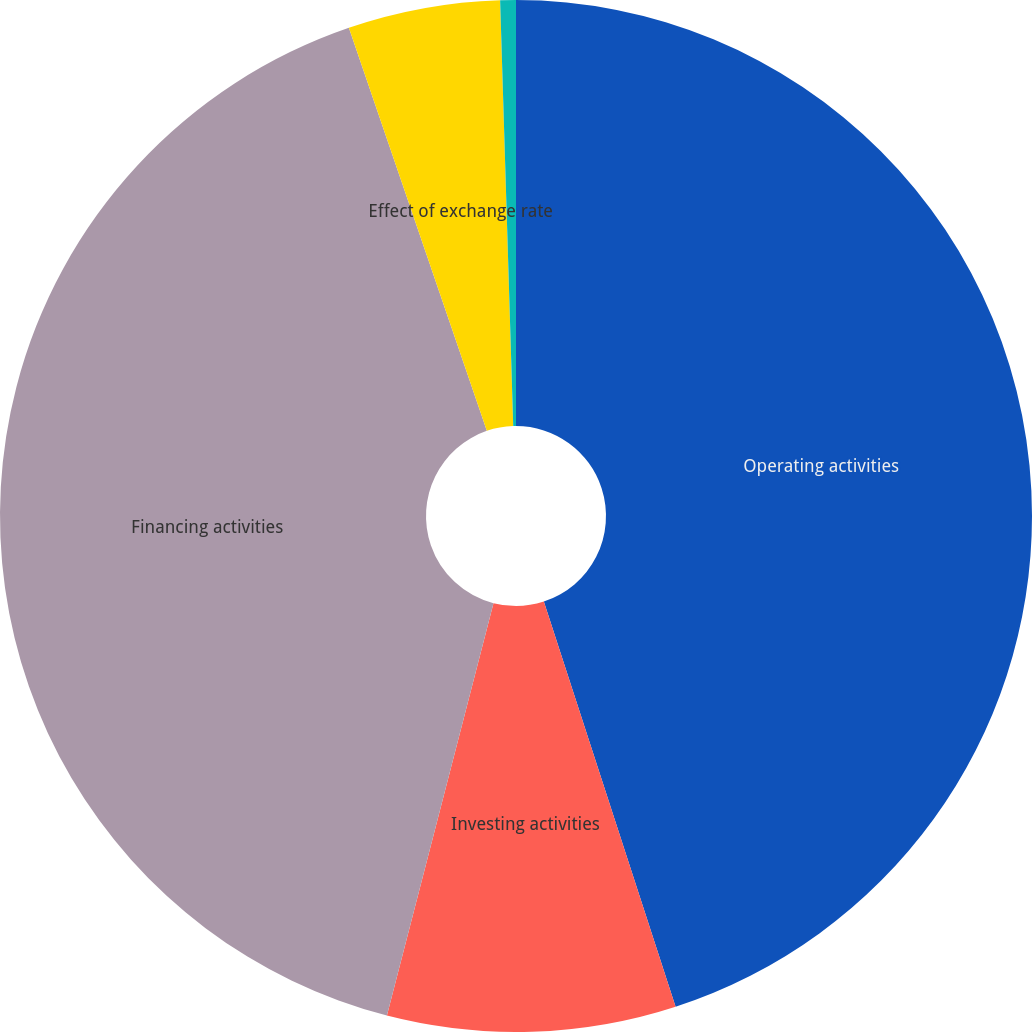Convert chart to OTSL. <chart><loc_0><loc_0><loc_500><loc_500><pie_chart><fcel>Operating activities<fcel>Investing activities<fcel>Financing activities<fcel>Effect of exchange rate<fcel>Increase (decrease) in cash<nl><fcel>45.0%<fcel>9.03%<fcel>40.73%<fcel>4.76%<fcel>0.49%<nl></chart> 